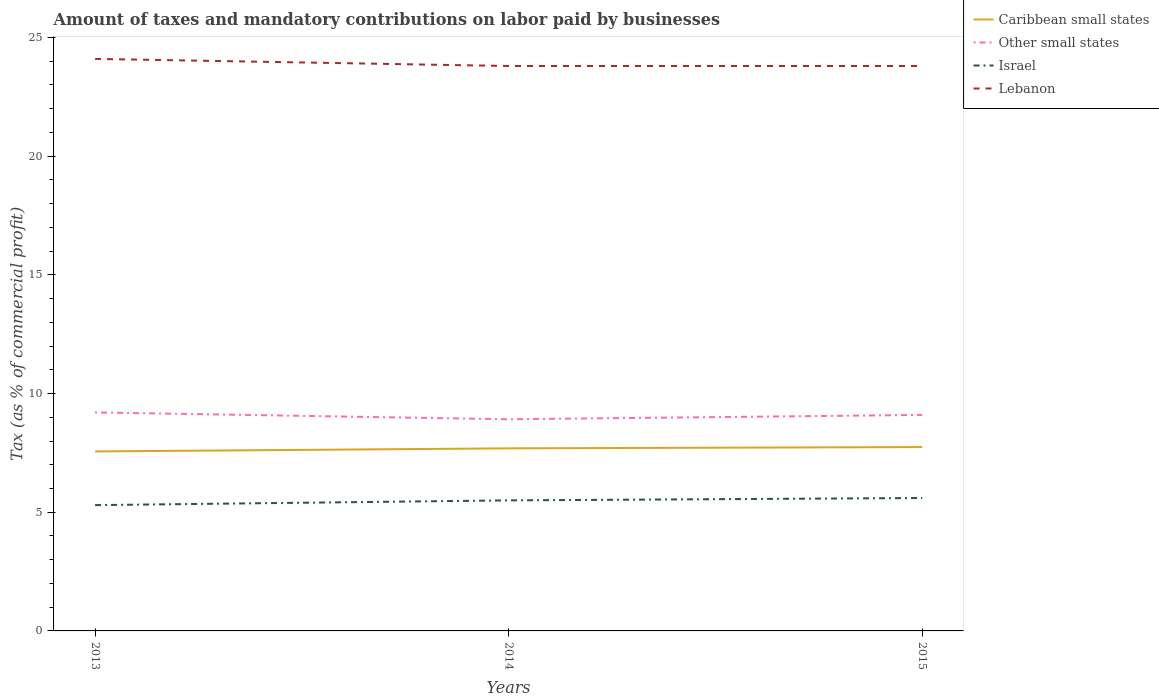Across all years, what is the maximum percentage of taxes paid by businesses in Caribbean small states?
Offer a very short reply. 7.56. In which year was the percentage of taxes paid by businesses in Other small states maximum?
Keep it short and to the point. 2014. What is the total percentage of taxes paid by businesses in Other small states in the graph?
Provide a succinct answer. -0.18. What is the difference between the highest and the second highest percentage of taxes paid by businesses in Lebanon?
Provide a succinct answer. 0.3. What is the difference between the highest and the lowest percentage of taxes paid by businesses in Lebanon?
Your answer should be very brief. 1. Are the values on the major ticks of Y-axis written in scientific E-notation?
Your response must be concise. No. Does the graph contain any zero values?
Provide a succinct answer. No. Where does the legend appear in the graph?
Offer a very short reply. Top right. How many legend labels are there?
Your answer should be compact. 4. How are the legend labels stacked?
Make the answer very short. Vertical. What is the title of the graph?
Make the answer very short. Amount of taxes and mandatory contributions on labor paid by businesses. Does "Lao PDR" appear as one of the legend labels in the graph?
Your answer should be very brief. No. What is the label or title of the X-axis?
Your response must be concise. Years. What is the label or title of the Y-axis?
Offer a very short reply. Tax (as % of commercial profit). What is the Tax (as % of commercial profit) of Caribbean small states in 2013?
Provide a short and direct response. 7.56. What is the Tax (as % of commercial profit) in Other small states in 2013?
Give a very brief answer. 9.21. What is the Tax (as % of commercial profit) of Lebanon in 2013?
Your answer should be very brief. 24.1. What is the Tax (as % of commercial profit) of Caribbean small states in 2014?
Your answer should be compact. 7.69. What is the Tax (as % of commercial profit) in Other small states in 2014?
Your response must be concise. 8.92. What is the Tax (as % of commercial profit) in Lebanon in 2014?
Keep it short and to the point. 23.8. What is the Tax (as % of commercial profit) in Caribbean small states in 2015?
Keep it short and to the point. 7.75. What is the Tax (as % of commercial profit) in Israel in 2015?
Offer a very short reply. 5.6. What is the Tax (as % of commercial profit) in Lebanon in 2015?
Your response must be concise. 23.8. Across all years, what is the maximum Tax (as % of commercial profit) in Caribbean small states?
Offer a terse response. 7.75. Across all years, what is the maximum Tax (as % of commercial profit) of Other small states?
Keep it short and to the point. 9.21. Across all years, what is the maximum Tax (as % of commercial profit) in Lebanon?
Give a very brief answer. 24.1. Across all years, what is the minimum Tax (as % of commercial profit) in Caribbean small states?
Keep it short and to the point. 7.56. Across all years, what is the minimum Tax (as % of commercial profit) of Other small states?
Provide a short and direct response. 8.92. Across all years, what is the minimum Tax (as % of commercial profit) in Lebanon?
Offer a terse response. 23.8. What is the total Tax (as % of commercial profit) in Other small states in the graph?
Ensure brevity in your answer.  27.22. What is the total Tax (as % of commercial profit) of Israel in the graph?
Keep it short and to the point. 16.4. What is the total Tax (as % of commercial profit) of Lebanon in the graph?
Keep it short and to the point. 71.7. What is the difference between the Tax (as % of commercial profit) of Caribbean small states in 2013 and that in 2014?
Offer a terse response. -0.13. What is the difference between the Tax (as % of commercial profit) of Other small states in 2013 and that in 2014?
Make the answer very short. 0.29. What is the difference between the Tax (as % of commercial profit) in Caribbean small states in 2013 and that in 2015?
Your response must be concise. -0.18. What is the difference between the Tax (as % of commercial profit) of Other small states in 2013 and that in 2015?
Ensure brevity in your answer.  0.11. What is the difference between the Tax (as % of commercial profit) of Israel in 2013 and that in 2015?
Provide a succinct answer. -0.3. What is the difference between the Tax (as % of commercial profit) of Caribbean small states in 2014 and that in 2015?
Your answer should be very brief. -0.05. What is the difference between the Tax (as % of commercial profit) of Other small states in 2014 and that in 2015?
Offer a very short reply. -0.18. What is the difference between the Tax (as % of commercial profit) in Israel in 2014 and that in 2015?
Your answer should be very brief. -0.1. What is the difference between the Tax (as % of commercial profit) in Caribbean small states in 2013 and the Tax (as % of commercial profit) in Other small states in 2014?
Your answer should be very brief. -1.36. What is the difference between the Tax (as % of commercial profit) in Caribbean small states in 2013 and the Tax (as % of commercial profit) in Israel in 2014?
Offer a very short reply. 2.06. What is the difference between the Tax (as % of commercial profit) in Caribbean small states in 2013 and the Tax (as % of commercial profit) in Lebanon in 2014?
Provide a short and direct response. -16.24. What is the difference between the Tax (as % of commercial profit) in Other small states in 2013 and the Tax (as % of commercial profit) in Israel in 2014?
Provide a short and direct response. 3.71. What is the difference between the Tax (as % of commercial profit) of Other small states in 2013 and the Tax (as % of commercial profit) of Lebanon in 2014?
Offer a very short reply. -14.59. What is the difference between the Tax (as % of commercial profit) of Israel in 2013 and the Tax (as % of commercial profit) of Lebanon in 2014?
Provide a succinct answer. -18.5. What is the difference between the Tax (as % of commercial profit) in Caribbean small states in 2013 and the Tax (as % of commercial profit) in Other small states in 2015?
Make the answer very short. -1.54. What is the difference between the Tax (as % of commercial profit) of Caribbean small states in 2013 and the Tax (as % of commercial profit) of Israel in 2015?
Provide a short and direct response. 1.96. What is the difference between the Tax (as % of commercial profit) of Caribbean small states in 2013 and the Tax (as % of commercial profit) of Lebanon in 2015?
Provide a short and direct response. -16.24. What is the difference between the Tax (as % of commercial profit) in Other small states in 2013 and the Tax (as % of commercial profit) in Israel in 2015?
Ensure brevity in your answer.  3.61. What is the difference between the Tax (as % of commercial profit) of Other small states in 2013 and the Tax (as % of commercial profit) of Lebanon in 2015?
Provide a short and direct response. -14.59. What is the difference between the Tax (as % of commercial profit) of Israel in 2013 and the Tax (as % of commercial profit) of Lebanon in 2015?
Offer a terse response. -18.5. What is the difference between the Tax (as % of commercial profit) in Caribbean small states in 2014 and the Tax (as % of commercial profit) in Other small states in 2015?
Your response must be concise. -1.41. What is the difference between the Tax (as % of commercial profit) of Caribbean small states in 2014 and the Tax (as % of commercial profit) of Israel in 2015?
Provide a short and direct response. 2.09. What is the difference between the Tax (as % of commercial profit) of Caribbean small states in 2014 and the Tax (as % of commercial profit) of Lebanon in 2015?
Your answer should be compact. -16.11. What is the difference between the Tax (as % of commercial profit) in Other small states in 2014 and the Tax (as % of commercial profit) in Israel in 2015?
Provide a short and direct response. 3.32. What is the difference between the Tax (as % of commercial profit) of Other small states in 2014 and the Tax (as % of commercial profit) of Lebanon in 2015?
Make the answer very short. -14.88. What is the difference between the Tax (as % of commercial profit) of Israel in 2014 and the Tax (as % of commercial profit) of Lebanon in 2015?
Your response must be concise. -18.3. What is the average Tax (as % of commercial profit) of Caribbean small states per year?
Make the answer very short. 7.67. What is the average Tax (as % of commercial profit) in Other small states per year?
Provide a succinct answer. 9.07. What is the average Tax (as % of commercial profit) of Israel per year?
Your answer should be compact. 5.47. What is the average Tax (as % of commercial profit) in Lebanon per year?
Offer a very short reply. 23.9. In the year 2013, what is the difference between the Tax (as % of commercial profit) in Caribbean small states and Tax (as % of commercial profit) in Other small states?
Offer a terse response. -1.64. In the year 2013, what is the difference between the Tax (as % of commercial profit) in Caribbean small states and Tax (as % of commercial profit) in Israel?
Give a very brief answer. 2.26. In the year 2013, what is the difference between the Tax (as % of commercial profit) of Caribbean small states and Tax (as % of commercial profit) of Lebanon?
Your answer should be compact. -16.54. In the year 2013, what is the difference between the Tax (as % of commercial profit) of Other small states and Tax (as % of commercial profit) of Israel?
Your answer should be compact. 3.91. In the year 2013, what is the difference between the Tax (as % of commercial profit) of Other small states and Tax (as % of commercial profit) of Lebanon?
Provide a succinct answer. -14.89. In the year 2013, what is the difference between the Tax (as % of commercial profit) of Israel and Tax (as % of commercial profit) of Lebanon?
Your answer should be compact. -18.8. In the year 2014, what is the difference between the Tax (as % of commercial profit) of Caribbean small states and Tax (as % of commercial profit) of Other small states?
Your answer should be very brief. -1.22. In the year 2014, what is the difference between the Tax (as % of commercial profit) of Caribbean small states and Tax (as % of commercial profit) of Israel?
Your response must be concise. 2.19. In the year 2014, what is the difference between the Tax (as % of commercial profit) in Caribbean small states and Tax (as % of commercial profit) in Lebanon?
Your answer should be very brief. -16.11. In the year 2014, what is the difference between the Tax (as % of commercial profit) in Other small states and Tax (as % of commercial profit) in Israel?
Your response must be concise. 3.42. In the year 2014, what is the difference between the Tax (as % of commercial profit) of Other small states and Tax (as % of commercial profit) of Lebanon?
Provide a short and direct response. -14.88. In the year 2014, what is the difference between the Tax (as % of commercial profit) of Israel and Tax (as % of commercial profit) of Lebanon?
Give a very brief answer. -18.3. In the year 2015, what is the difference between the Tax (as % of commercial profit) of Caribbean small states and Tax (as % of commercial profit) of Other small states?
Ensure brevity in your answer.  -1.35. In the year 2015, what is the difference between the Tax (as % of commercial profit) in Caribbean small states and Tax (as % of commercial profit) in Israel?
Offer a terse response. 2.15. In the year 2015, what is the difference between the Tax (as % of commercial profit) of Caribbean small states and Tax (as % of commercial profit) of Lebanon?
Offer a terse response. -16.05. In the year 2015, what is the difference between the Tax (as % of commercial profit) of Other small states and Tax (as % of commercial profit) of Lebanon?
Make the answer very short. -14.7. In the year 2015, what is the difference between the Tax (as % of commercial profit) in Israel and Tax (as % of commercial profit) in Lebanon?
Give a very brief answer. -18.2. What is the ratio of the Tax (as % of commercial profit) in Caribbean small states in 2013 to that in 2014?
Provide a short and direct response. 0.98. What is the ratio of the Tax (as % of commercial profit) of Other small states in 2013 to that in 2014?
Offer a very short reply. 1.03. What is the ratio of the Tax (as % of commercial profit) in Israel in 2013 to that in 2014?
Make the answer very short. 0.96. What is the ratio of the Tax (as % of commercial profit) in Lebanon in 2013 to that in 2014?
Your answer should be very brief. 1.01. What is the ratio of the Tax (as % of commercial profit) in Caribbean small states in 2013 to that in 2015?
Keep it short and to the point. 0.98. What is the ratio of the Tax (as % of commercial profit) of Other small states in 2013 to that in 2015?
Your answer should be compact. 1.01. What is the ratio of the Tax (as % of commercial profit) in Israel in 2013 to that in 2015?
Your answer should be compact. 0.95. What is the ratio of the Tax (as % of commercial profit) of Lebanon in 2013 to that in 2015?
Offer a terse response. 1.01. What is the ratio of the Tax (as % of commercial profit) of Caribbean small states in 2014 to that in 2015?
Give a very brief answer. 0.99. What is the ratio of the Tax (as % of commercial profit) in Other small states in 2014 to that in 2015?
Your response must be concise. 0.98. What is the ratio of the Tax (as % of commercial profit) of Israel in 2014 to that in 2015?
Offer a terse response. 0.98. What is the difference between the highest and the second highest Tax (as % of commercial profit) of Caribbean small states?
Ensure brevity in your answer.  0.05. What is the difference between the highest and the second highest Tax (as % of commercial profit) in Other small states?
Offer a terse response. 0.11. What is the difference between the highest and the second highest Tax (as % of commercial profit) of Israel?
Your response must be concise. 0.1. What is the difference between the highest and the lowest Tax (as % of commercial profit) of Caribbean small states?
Ensure brevity in your answer.  0.18. What is the difference between the highest and the lowest Tax (as % of commercial profit) of Other small states?
Provide a succinct answer. 0.29. What is the difference between the highest and the lowest Tax (as % of commercial profit) of Israel?
Offer a very short reply. 0.3. 